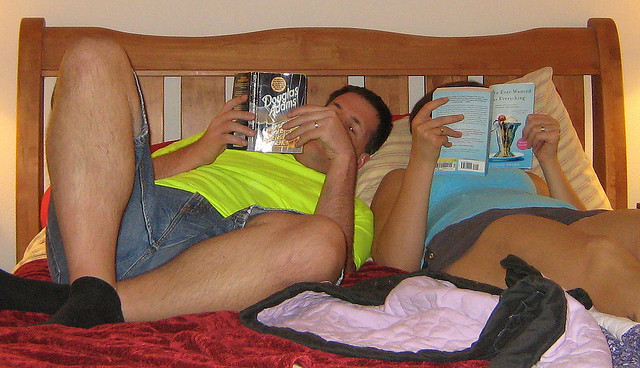Identify the text contained in this image. Doualas Addms 